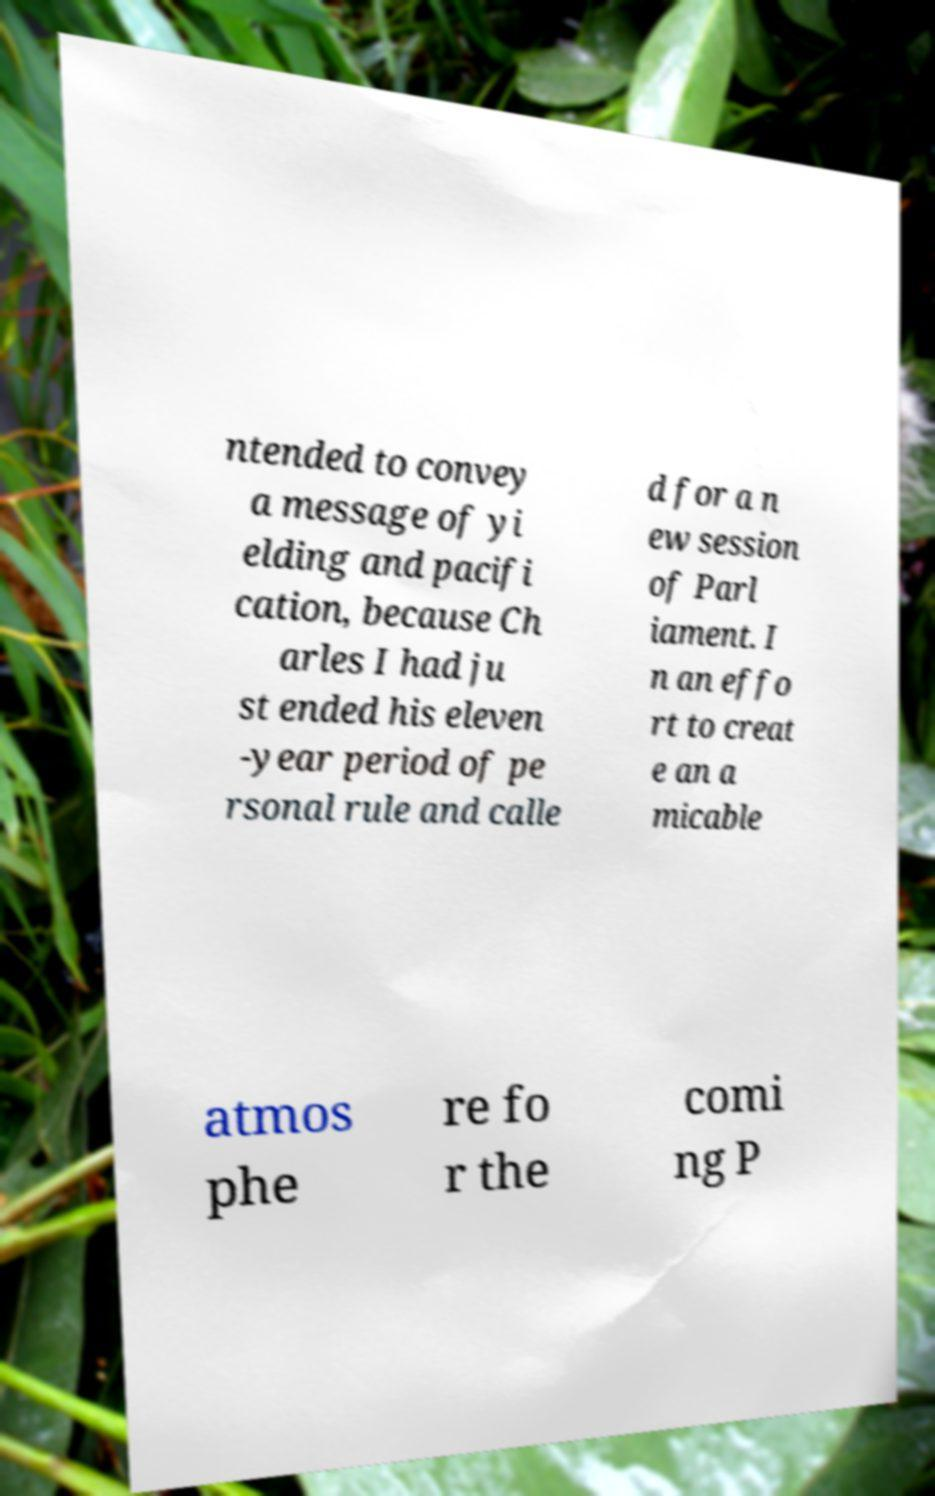For documentation purposes, I need the text within this image transcribed. Could you provide that? ntended to convey a message of yi elding and pacifi cation, because Ch arles I had ju st ended his eleven -year period of pe rsonal rule and calle d for a n ew session of Parl iament. I n an effo rt to creat e an a micable atmos phe re fo r the comi ng P 